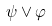Convert formula to latex. <formula><loc_0><loc_0><loc_500><loc_500>\psi \vee \varphi</formula> 